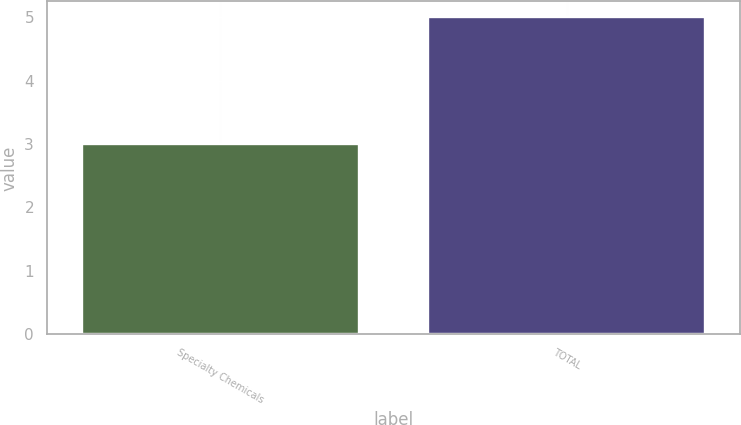Convert chart to OTSL. <chart><loc_0><loc_0><loc_500><loc_500><bar_chart><fcel>Specialty Chemicals<fcel>TOTAL<nl><fcel>3<fcel>5<nl></chart> 